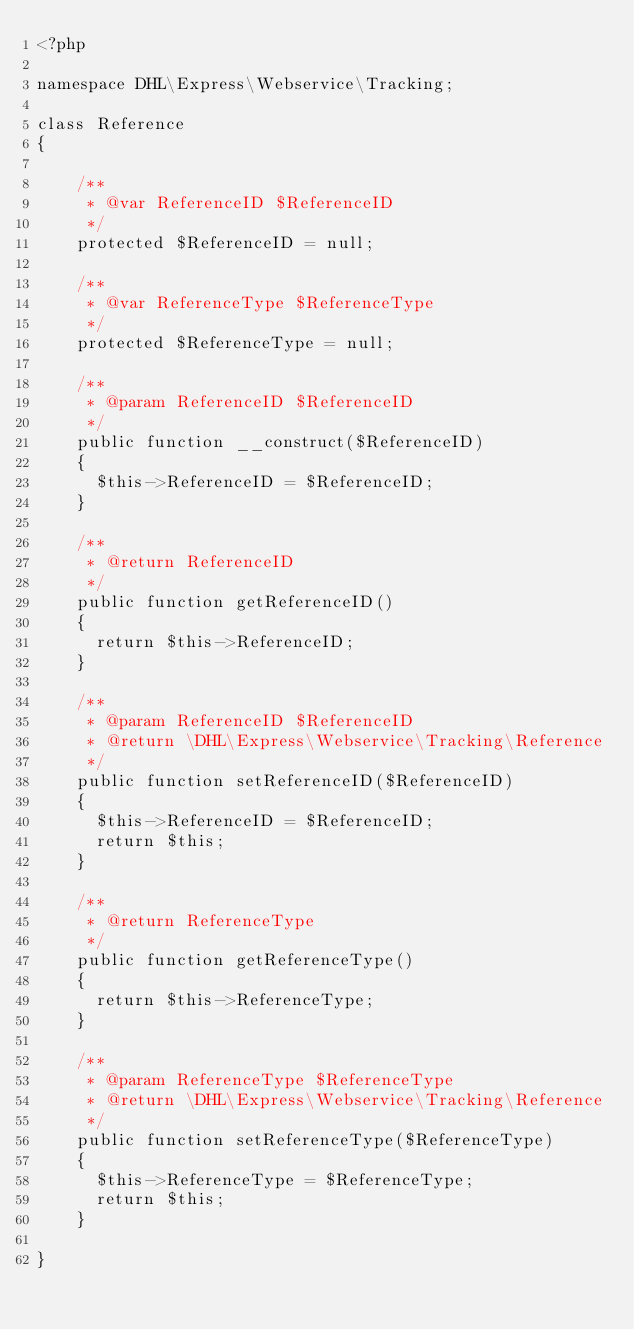Convert code to text. <code><loc_0><loc_0><loc_500><loc_500><_PHP_><?php

namespace DHL\Express\Webservice\Tracking;

class Reference
{

    /**
     * @var ReferenceID $ReferenceID
     */
    protected $ReferenceID = null;

    /**
     * @var ReferenceType $ReferenceType
     */
    protected $ReferenceType = null;

    /**
     * @param ReferenceID $ReferenceID
     */
    public function __construct($ReferenceID)
    {
      $this->ReferenceID = $ReferenceID;
    }

    /**
     * @return ReferenceID
     */
    public function getReferenceID()
    {
      return $this->ReferenceID;
    }

    /**
     * @param ReferenceID $ReferenceID
     * @return \DHL\Express\Webservice\Tracking\Reference
     */
    public function setReferenceID($ReferenceID)
    {
      $this->ReferenceID = $ReferenceID;
      return $this;
    }

    /**
     * @return ReferenceType
     */
    public function getReferenceType()
    {
      return $this->ReferenceType;
    }

    /**
     * @param ReferenceType $ReferenceType
     * @return \DHL\Express\Webservice\Tracking\Reference
     */
    public function setReferenceType($ReferenceType)
    {
      $this->ReferenceType = $ReferenceType;
      return $this;
    }

}
</code> 